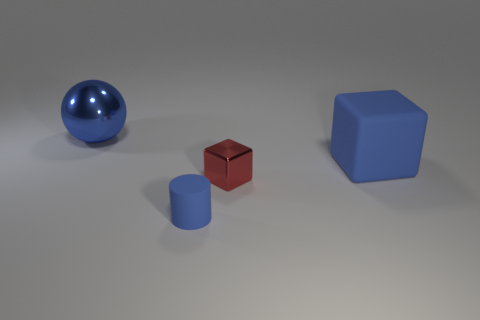There is a blue rubber object that is the same size as the red metal object; what is its shape?
Keep it short and to the point. Cylinder. How many rubber objects are red spheres or red blocks?
Your answer should be compact. 0. Are the tiny thing that is on the left side of the tiny block and the blue object that is on the right side of the red metallic thing made of the same material?
Offer a very short reply. Yes. There is a cube that is made of the same material as the small cylinder; what color is it?
Offer a very short reply. Blue. Is the number of matte cubes behind the small red shiny block greater than the number of objects on the left side of the big blue rubber cube?
Your answer should be very brief. No. Is there a large purple object?
Provide a succinct answer. No. What is the material of the cylinder that is the same color as the metallic sphere?
Make the answer very short. Rubber. How many objects are either large purple shiny cylinders or blue metal spheres?
Make the answer very short. 1. Is there another big block that has the same color as the large rubber block?
Your response must be concise. No. There is a blue thing that is right of the tiny cube; what number of red metallic cubes are in front of it?
Provide a succinct answer. 1. 